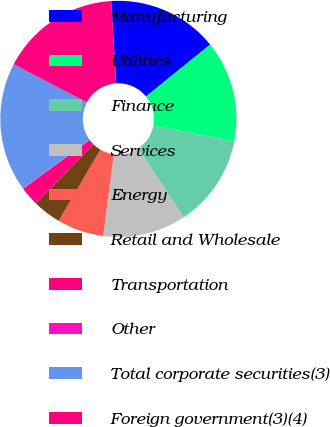Convert chart. <chart><loc_0><loc_0><loc_500><loc_500><pie_chart><fcel>Manufacturing<fcel>Utilities<fcel>Finance<fcel>Services<fcel>Energy<fcel>Retail and Wholesale<fcel>Transportation<fcel>Other<fcel>Total corporate securities(3)<fcel>Foreign government(3)(4)<nl><fcel>15.13%<fcel>13.88%<fcel>12.63%<fcel>11.38%<fcel>6.37%<fcel>3.87%<fcel>2.62%<fcel>0.11%<fcel>17.63%<fcel>16.38%<nl></chart> 